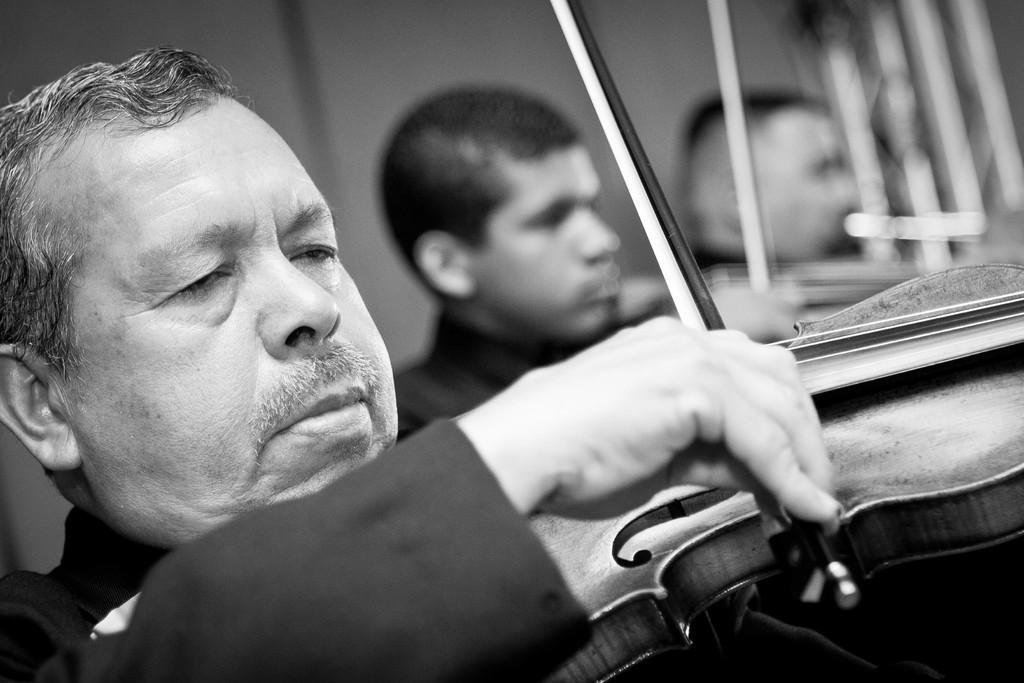Can you describe this image briefly? This is a black and white picture, there are three persons playing a music instrument. Behind the people is in blue. 